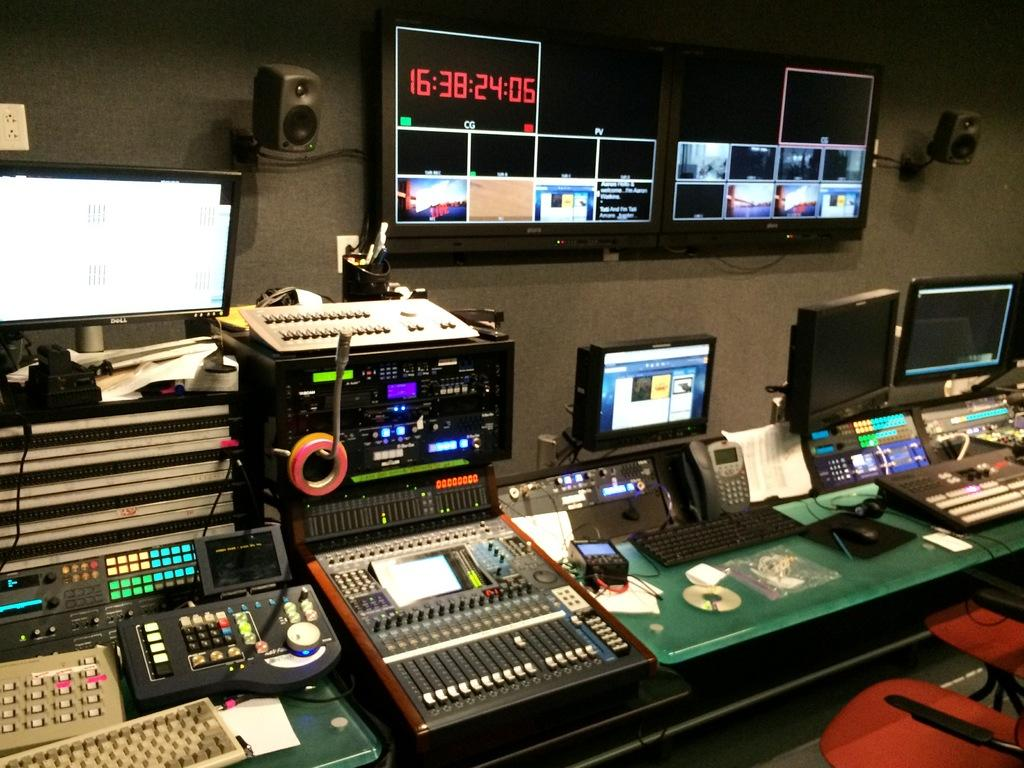<image>
Write a terse but informative summary of the picture. A digital screen in a control room has numbers on it, the first being 16. 